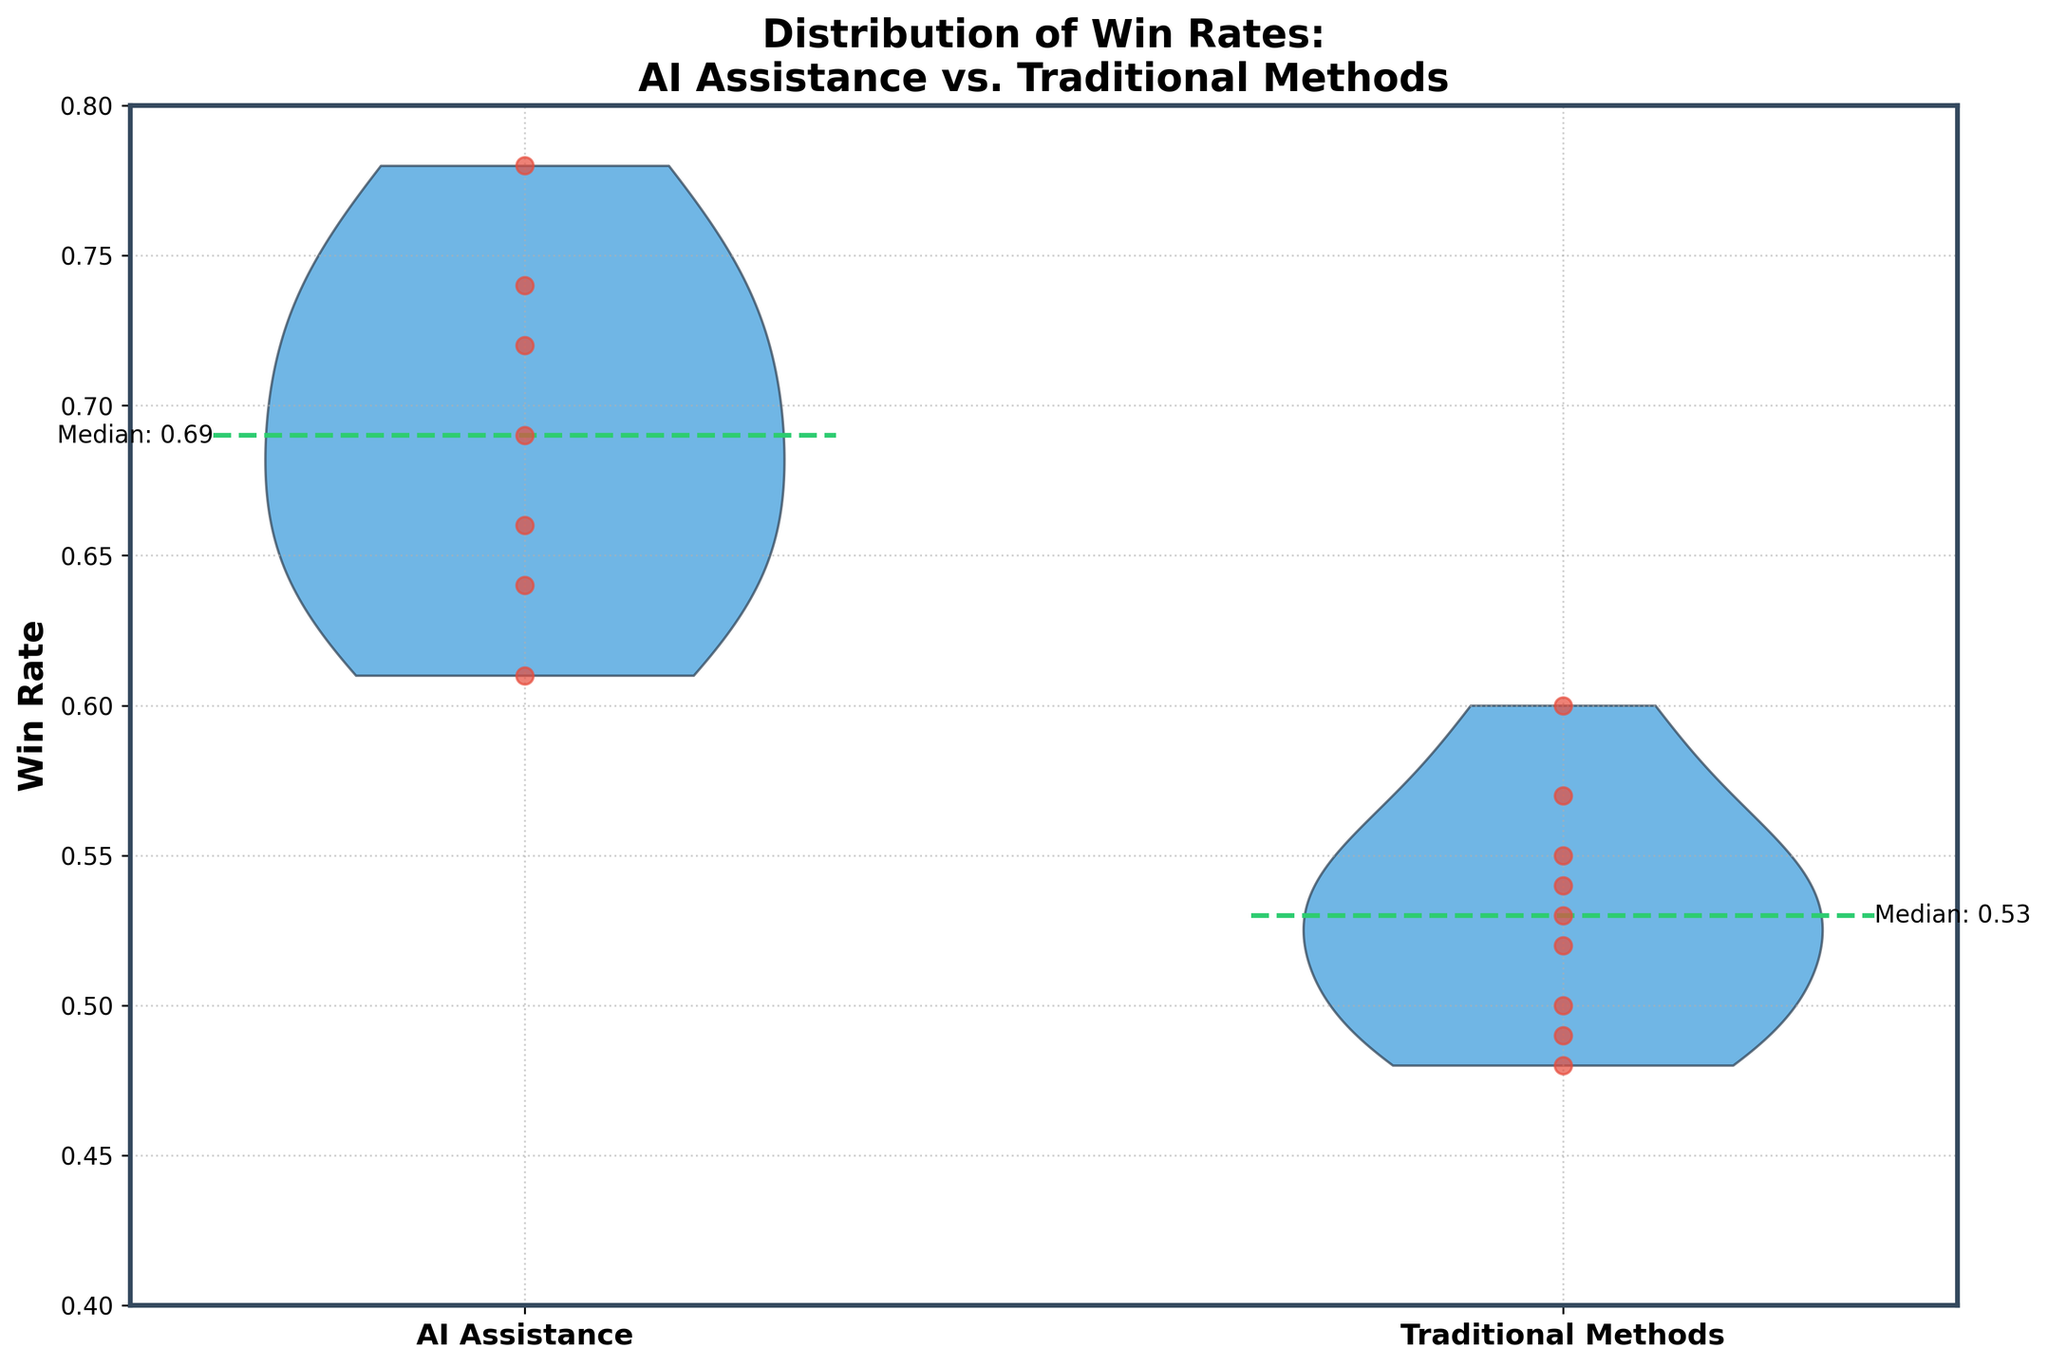What's the overall title of the plot? The title is typically located at the top of the figure. In this case, the title reads "Distribution of Win Rates: AI Assistance vs. Traditional Methods".
Answer: "Distribution of Win Rates: AI Assistance vs. Traditional Methods" What methods are being compared in the plot? The x-axis labels show the two groups being compared. They are "AI Assistance" and "Traditional Methods".
Answer: AI Assistance, Traditional Methods What is the range of win rates shown on the y-axis? The y-axis shows the range of win rates, which starts from 0.4 and goes up to 0.8.
Answer: 0.4 to 0.8 How many data points are there for each method? By counting the dots representing each observation in the scatter layer over the violin plot, we can see that there are 7 for "AI Assistance" and 8 for "Traditional Methods".
Answer: 7 for AI Assistance, 8 for Traditional Methods What color represents the individual data points in the scatter part of the plot? The individual data points in the scatter plot are colored red.
Answer: Red Which method has the higher median win rate? The green dashed horizontal lines indicate the medians. The median win rate for "AI Assistance" is higher than that for "Traditional Methods".
Answer: AI Assistance What is the value of the median win rate for AI Assistance? According to the text annotation next to the green dashed horizontal line for "AI Assistance", the median win rate is 0.69.
Answer: 0.69 Is the median win rate for Traditional Methods higher or lower than 0.55? The green dashed horizontal line for "Traditional Methods" is annotated with the median value of 0.53, which is lower than 0.55.
Answer: Lower What is the range of values covered by the violin plot for AI Assistance? The width of the violin plot for AI Assistance spans approximately from 0.60 to 0.78.
Answer: 0.60 to 0.78 Between AI Assistance and Traditional Methods, which has a more concentrated distribution of win rates? AI Assistance has a more concentrated distribution as its violin plot is narrower compared to the wider distribution of Traditional Methods.
Answer: AI Assistance 